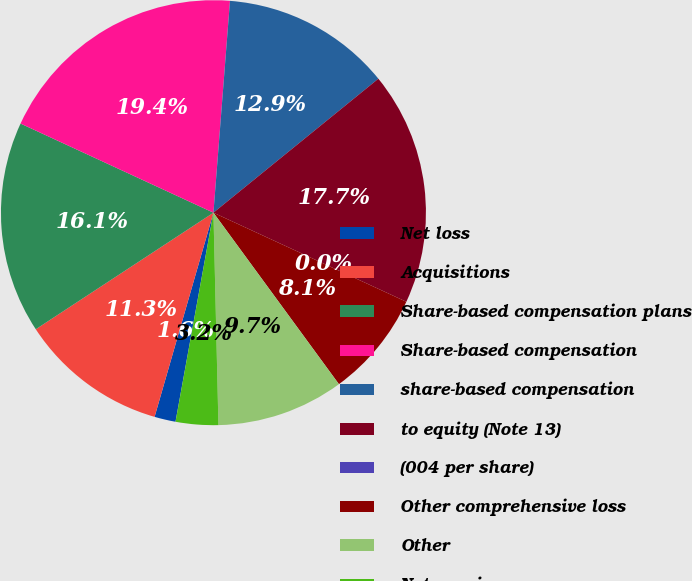Convert chart. <chart><loc_0><loc_0><loc_500><loc_500><pie_chart><fcel>Net loss<fcel>Acquisitions<fcel>Share-based compensation plans<fcel>Share-based compensation<fcel>share-based compensation<fcel>to equity (Note 13)<fcel>(004 per share)<fcel>Other comprehensive loss<fcel>Other<fcel>Net earnings<nl><fcel>1.61%<fcel>11.29%<fcel>16.13%<fcel>19.35%<fcel>12.9%<fcel>17.74%<fcel>0.0%<fcel>8.06%<fcel>9.68%<fcel>3.23%<nl></chart> 